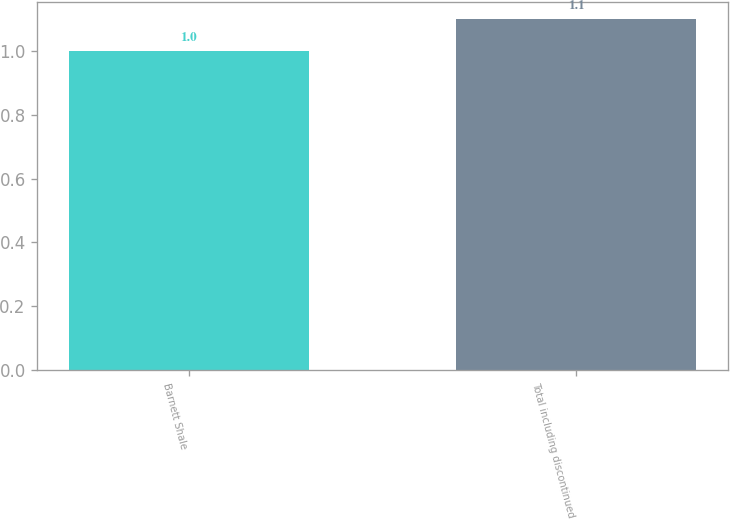<chart> <loc_0><loc_0><loc_500><loc_500><bar_chart><fcel>Barnett Shale<fcel>Total including discontinued<nl><fcel>1<fcel>1.1<nl></chart> 